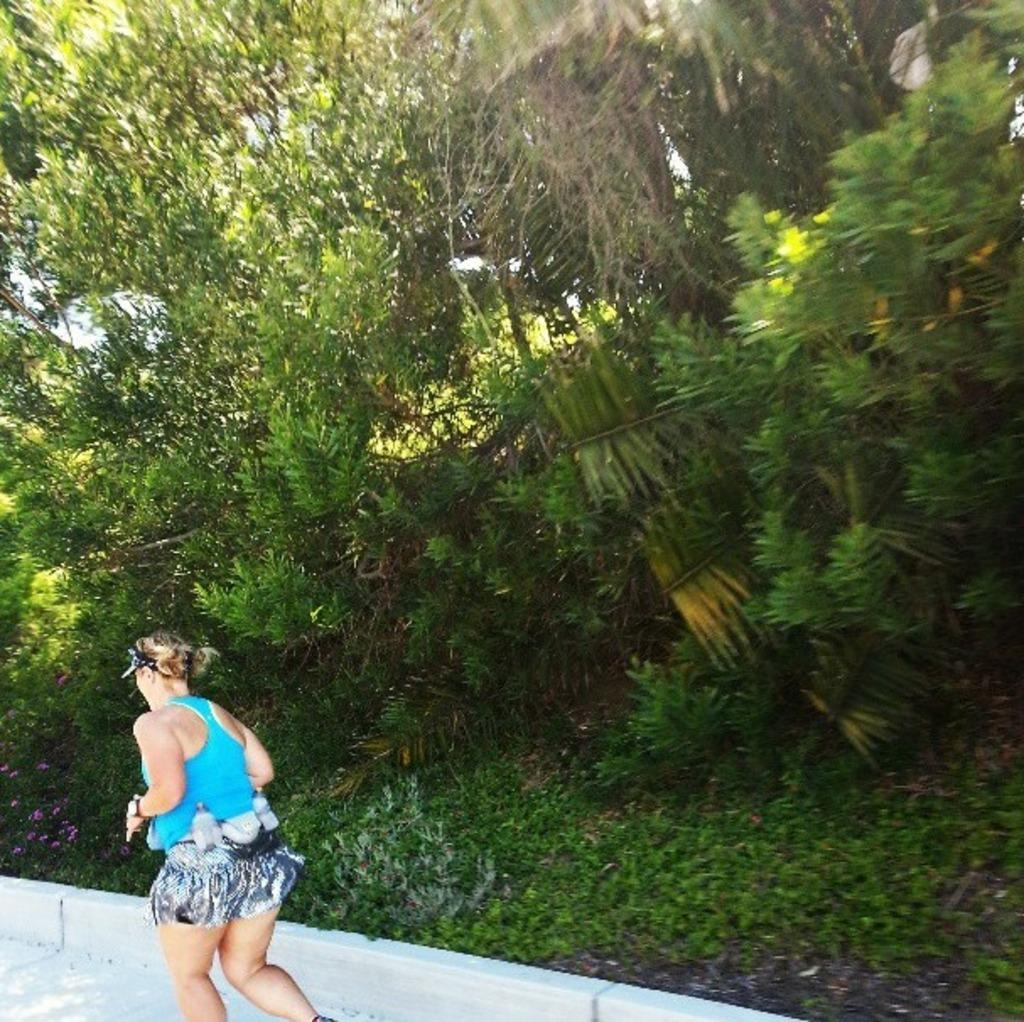Who is the main subject in the image? There is a woman in the image. What is the woman wearing? The woman is wearing a blue t-shirt. What activity is the woman engaged in? The woman is running on a footpath. What is the location of the woman in relation to the wall? The woman is near a wall. What can be seen in the background of the image? There are trees and the sky visible in the background of the image. What type of drum can be heard playing in the background of the image? There is no drum or sound present in the image; it is a still photograph of a woman running. 